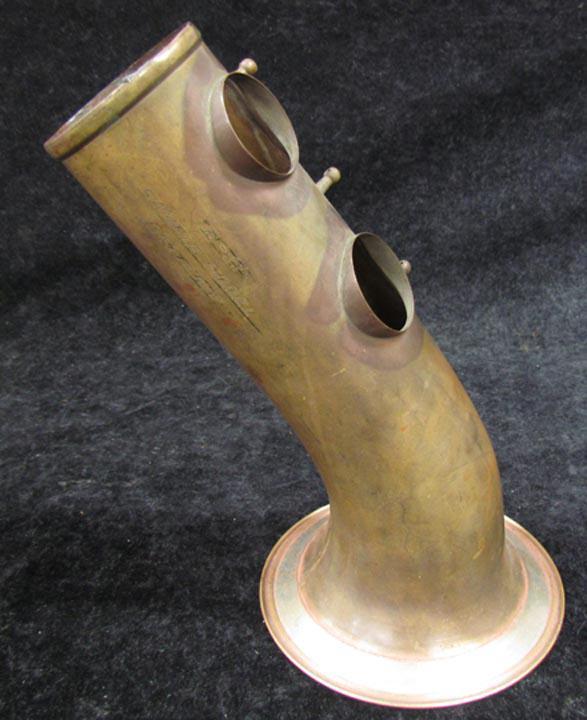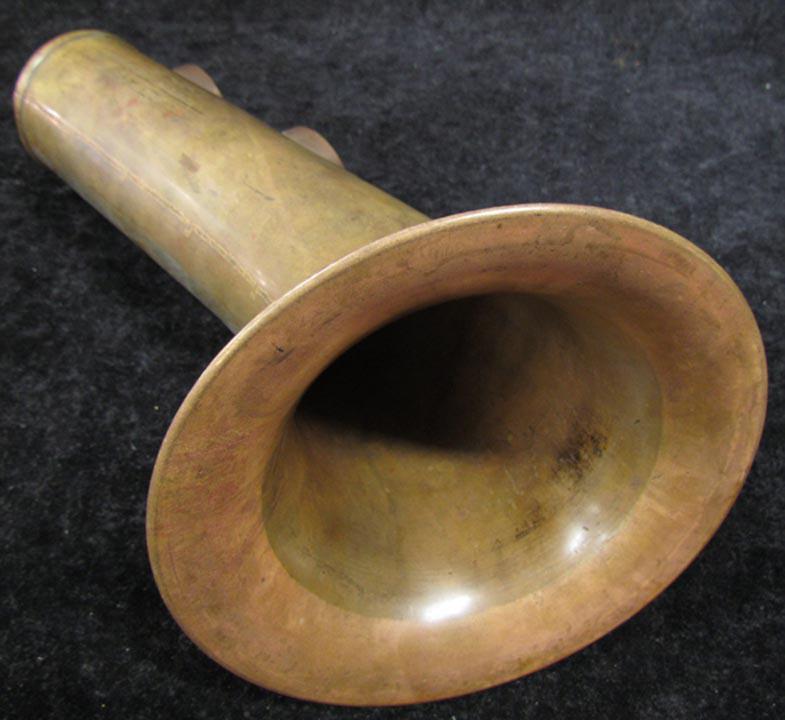The first image is the image on the left, the second image is the image on the right. For the images displayed, is the sentence "A man in a short-sleeved black shirt is holding a saxophone." factually correct? Answer yes or no. No. The first image is the image on the left, the second image is the image on the right. Examine the images to the left and right. Is the description "A man is holding the saxophone in the image on the right." accurate? Answer yes or no. No. 